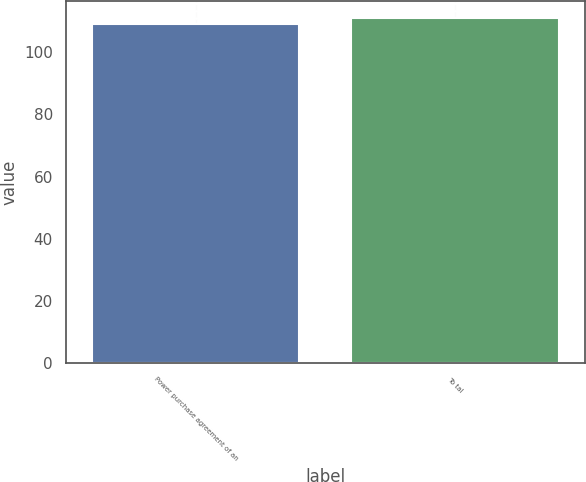<chart> <loc_0><loc_0><loc_500><loc_500><bar_chart><fcel>Power purchase agreement of an<fcel>To tal<nl><fcel>109<fcel>111<nl></chart> 